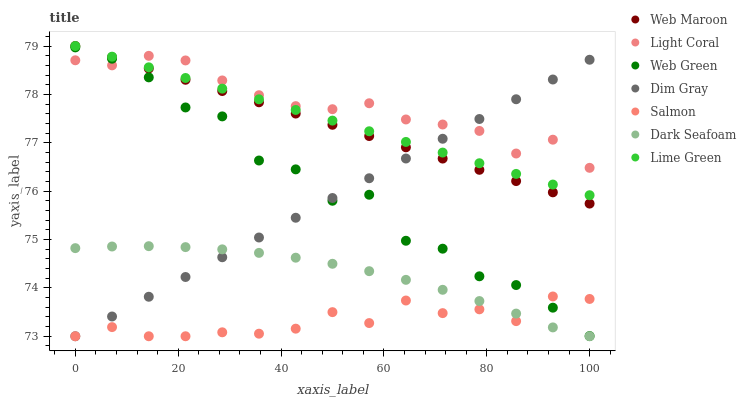Does Salmon have the minimum area under the curve?
Answer yes or no. Yes. Does Light Coral have the maximum area under the curve?
Answer yes or no. Yes. Does Web Maroon have the minimum area under the curve?
Answer yes or no. No. Does Web Maroon have the maximum area under the curve?
Answer yes or no. No. Is Dim Gray the smoothest?
Answer yes or no. Yes. Is Web Green the roughest?
Answer yes or no. Yes. Is Web Maroon the smoothest?
Answer yes or no. No. Is Web Maroon the roughest?
Answer yes or no. No. Does Dim Gray have the lowest value?
Answer yes or no. Yes. Does Web Maroon have the lowest value?
Answer yes or no. No. Does Lime Green have the highest value?
Answer yes or no. Yes. Does Salmon have the highest value?
Answer yes or no. No. Is Salmon less than Light Coral?
Answer yes or no. Yes. Is Web Green greater than Dark Seafoam?
Answer yes or no. Yes. Does Dim Gray intersect Light Coral?
Answer yes or no. Yes. Is Dim Gray less than Light Coral?
Answer yes or no. No. Is Dim Gray greater than Light Coral?
Answer yes or no. No. Does Salmon intersect Light Coral?
Answer yes or no. No. 